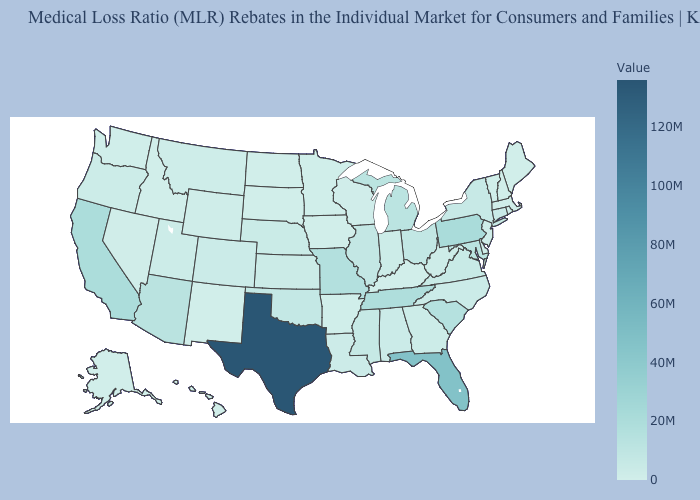Does West Virginia have a higher value than Florida?
Keep it brief. No. Does the map have missing data?
Answer briefly. No. Does Texas have the lowest value in the USA?
Be succinct. No. Does Rhode Island have the highest value in the Northeast?
Quick response, please. No. 